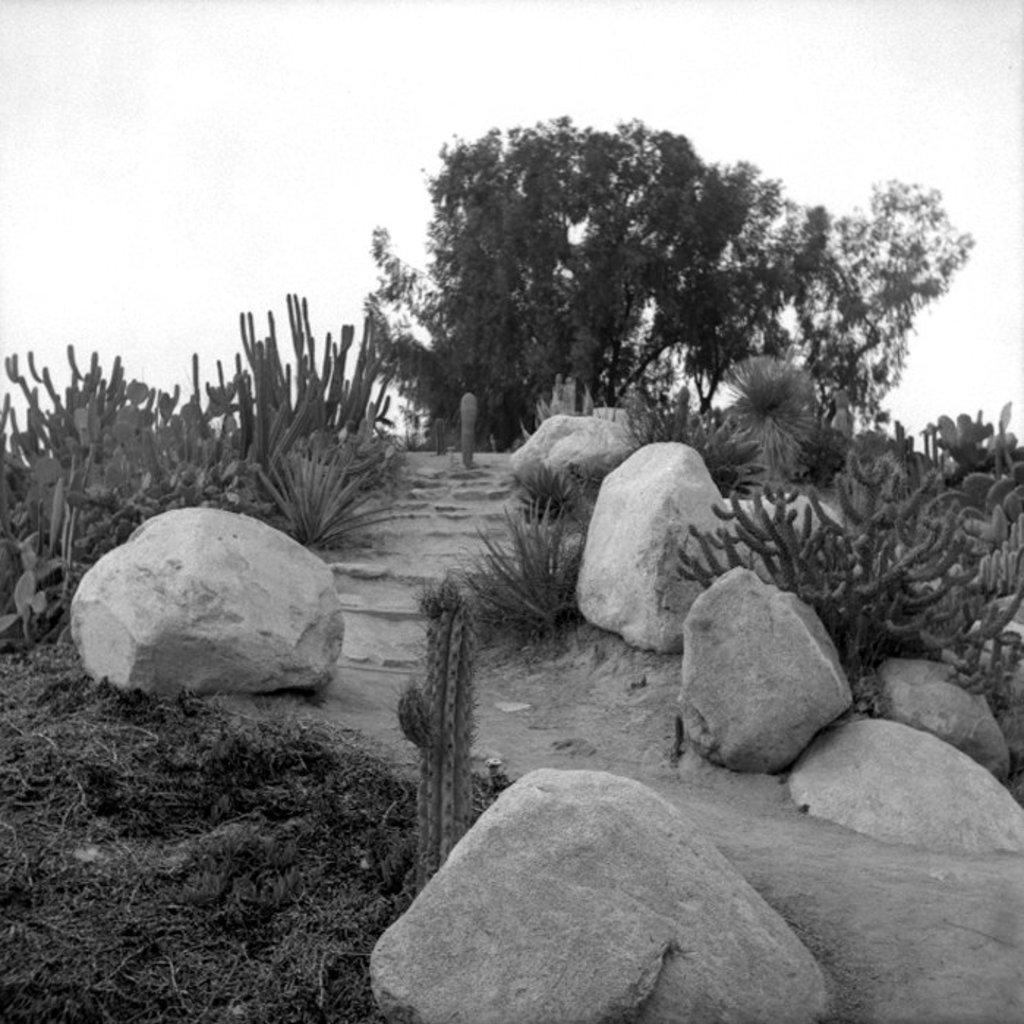What is the color scheme of the image? The image is black and white. What type of vegetation can be seen in the image? There is grass, plants, and trees in the image. What other objects are present in the image? There are rocks and a path in the image. What can be seen in the background of the image? The sky is visible in the background of the image. What type of animal can be seen crying in the image? There are no animals present in the image, and no one is crying. What type of flag is visible in the image? There is no flag present in the image. 